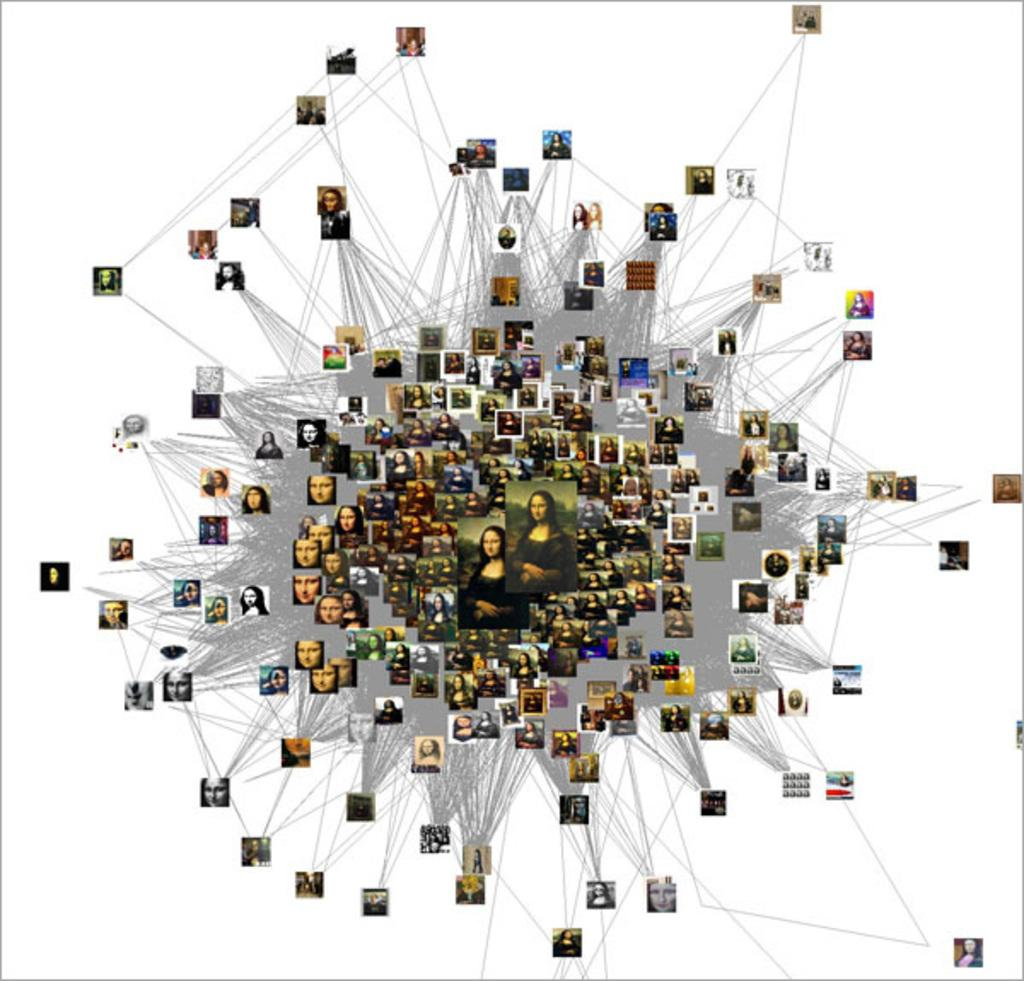What type of art is featured in the image? The image contains digital art. What famous artwork is included in the digital art? The digital art features the Mona Lisa. How many photographs of the Mona Lisa are present in the image? There are multiple photographs of the Mona Lisa in the image. What color is the background of the image? The background of the image is white. Can you see a wheel in the image? There is no wheel present in the image. Is there an airplane visible in the image? There is no airplane present in the image. 